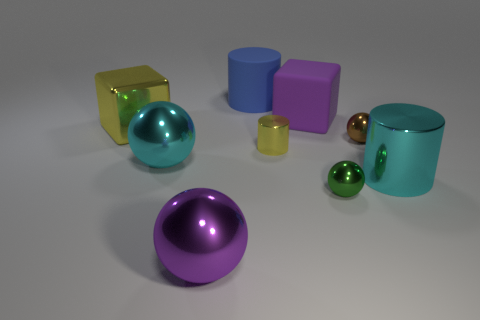Are there any metallic blocks of the same color as the small metal cylinder?
Offer a very short reply. Yes. There is a thing that is the same color as the tiny metal cylinder; what is its size?
Your response must be concise. Large. What number of other things are there of the same shape as the big yellow shiny thing?
Ensure brevity in your answer.  1. What is the material of the tiny cylinder behind the cyan metal object that is behind the big cyan cylinder?
Make the answer very short. Metal. Is the tiny green thing made of the same material as the large cylinder that is in front of the big yellow shiny thing?
Keep it short and to the point. Yes. There is a cylinder that is in front of the brown ball and left of the purple cube; what is its material?
Make the answer very short. Metal. There is a large block that is on the left side of the purple object that is in front of the large yellow metal object; what color is it?
Your response must be concise. Yellow. What is the material of the cyan thing that is on the right side of the purple sphere?
Your answer should be compact. Metal. Is the number of big yellow cubes less than the number of big brown rubber cylinders?
Offer a very short reply. No. There is a tiny yellow thing; is it the same shape as the large thing that is on the right side of the large purple block?
Your answer should be very brief. Yes. 